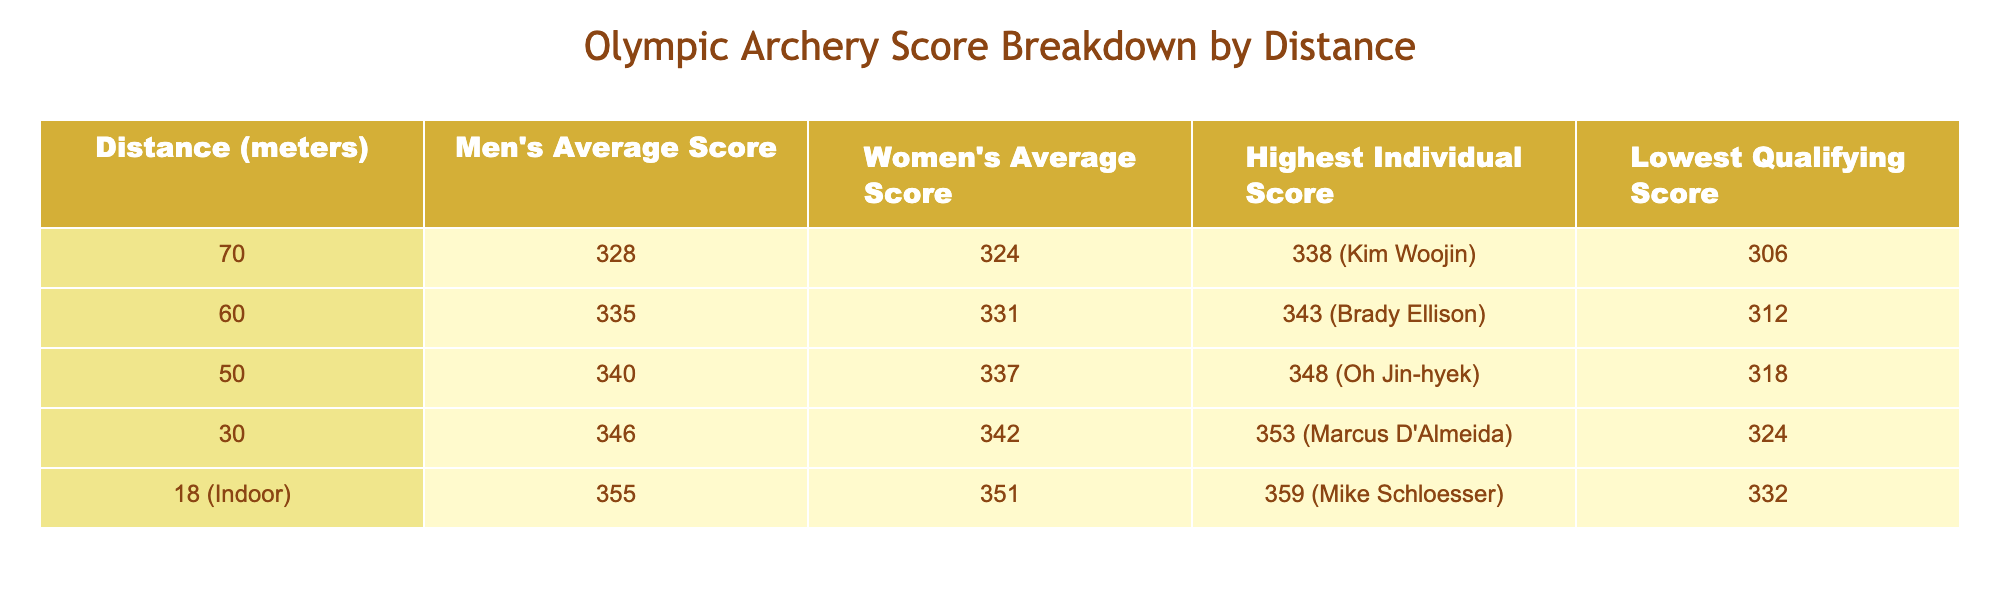What is the highest individual score recorded in men's Olympic archery? The table shows the highest individual score for men's archery as 338, achieved by Kim Woojin.
Answer: 338 Which gender has a higher average score at 50 meters? The table lists the men's average score at 50 meters as 340 and the women's as 337. Since 340 is greater than 337, men have a higher average score.
Answer: Men What is the difference between the highest individual score and the lowest qualifying score at 30 meters? The highest individual score at 30 meters is 353, and the lowest qualifying score is 324. To find the difference, we subtract 324 from 353: 353 - 324 = 29.
Answer: 29 Is the average women's score at 60 meters greater than the average score at 70 meters? The average women's score at 60 meters is 331 and at 70 meters is 324. Since 331 is greater than 324, the statement is true.
Answer: Yes What is the average score of men and women combined at 30 meters? The average scores at 30 meters are 346 for men and 342 for women. To find the combined average, we add them together and divide by 2: (346 + 342) / 2 = 344.
Answer: 344 How does the highest individual score at 18 meters compare to the lowest qualifying score at 60 meters? The highest individual score at 18 meters is 359 and the lowest qualifying score at 60 meters is 312. Since 359 is greater than 312, it indicates that the highest score exceeds the lowest qualifying score.
Answer: Yes What is the trend in average scores as distances increase from 30 meters to 70 meters for men? Observing the men's average scores: 346 (30m), 340 (50m), 335 (60m), 328 (70m). They decrease consistently from 346 to 328 as the distance increases.
Answer: Decreasing What is the average of the highest individual scores across all distances? The individual scores are 338 (70m), 343 (60m), 348 (50m), 353 (30m), and 359 (18m). Adding these gives 338 + 343 + 348 + 353 + 359 = 1741. Dividing by 5, the average is 1741 / 5 = 348.2.
Answer: 348.2 How many meters is the indoor event compared to the outdoor event distance? The indoor event is 18 meters while the outdoor distance is primarily 70 meters. 70 - 18 = 52. Thus, the outdoor distance is 52 meters longer.
Answer: 52 meters 